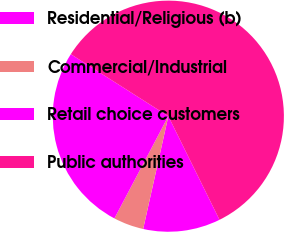<chart> <loc_0><loc_0><loc_500><loc_500><pie_chart><fcel>Residential/Religious (b)<fcel>Commercial/Industrial<fcel>Retail choice customers<fcel>Public authorities<nl><fcel>10.8%<fcel>4.23%<fcel>26.29%<fcel>58.69%<nl></chart> 